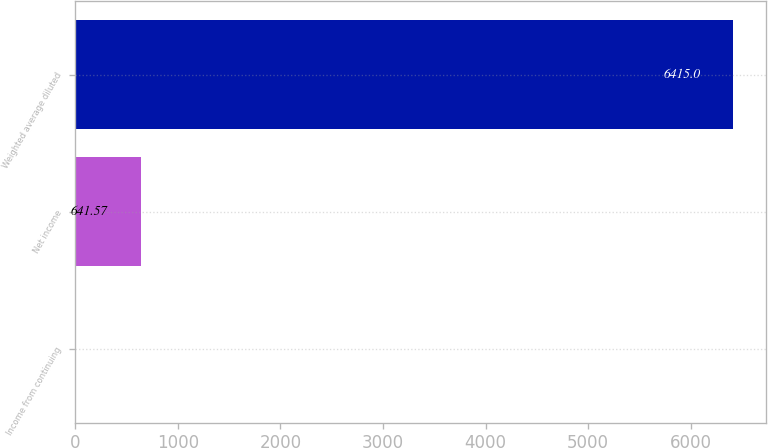Convert chart to OTSL. <chart><loc_0><loc_0><loc_500><loc_500><bar_chart><fcel>Income from continuing<fcel>Net income<fcel>Weighted average diluted<nl><fcel>0.08<fcel>641.57<fcel>6415<nl></chart> 